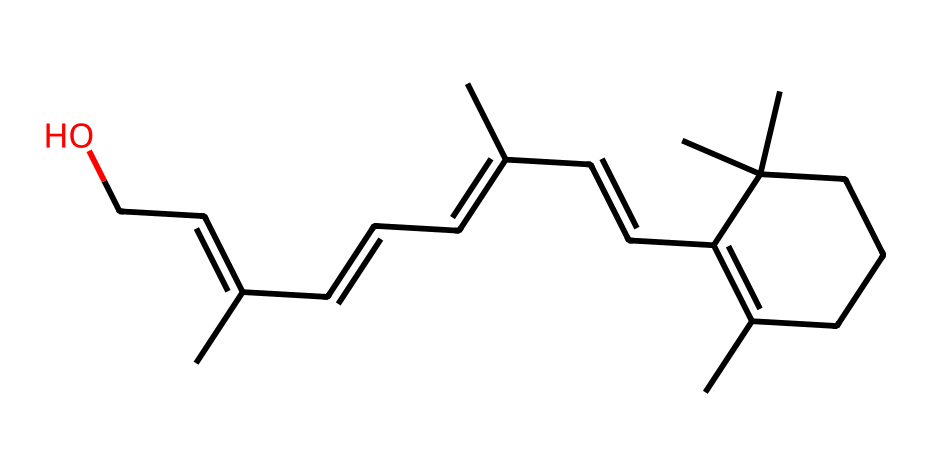What is the molecular formula of this compound? To determine the molecular formula, we need to count the number of carbon (C), hydrogen (H), and oxygen (O) atoms in the SMILES representation. The structure contains 27 carbon atoms, 46 hydrogen atoms, and 1 oxygen atom. Therefore, the molecular formula is C27H46O.
Answer: C27H46O How many double bonds are present in this structure? By analyzing the structure's SMILES, we look for carbon atoms that are connected by double bonds. The presence of "C=C" in the SMILES indicates double bonds. In total, there are 5 double bonds in the structure.
Answer: 5 What type of isomerism is shown by retinol's geometric isomers? Retinol has geometric isomers, specifically cis and trans isomers, which are differentiated by the spatial arrangement of groups around the double bonds. The presence of double bonds in the structure allows for this type of isomerism.
Answer: geometric isomerism Which functional group is present in this structure? The presence of "CCO" in the SMILES indicates a hydroxyl (-OH) group, which is characteristic of alcohols. The -OH functional group is responsible for the compound's alcohol properties.
Answer: hydroxyl How many chiral centers are in this molecule? Chiral centers are determined by carbon atoms bonded to four different substituents. By inspecting the structure, we can find that there are 3 carbon atoms that fit this criterion, making them chiral centers.
Answer: 3 What is the significance of geometric isomers in architectural coatings? Geometric isomers can influence the properties such as adhesion, flexibility, and drying time of coatings. Different configurations of molecules result in varied physical properties, which can be essential for performance in varied applications.
Answer: influence properties 